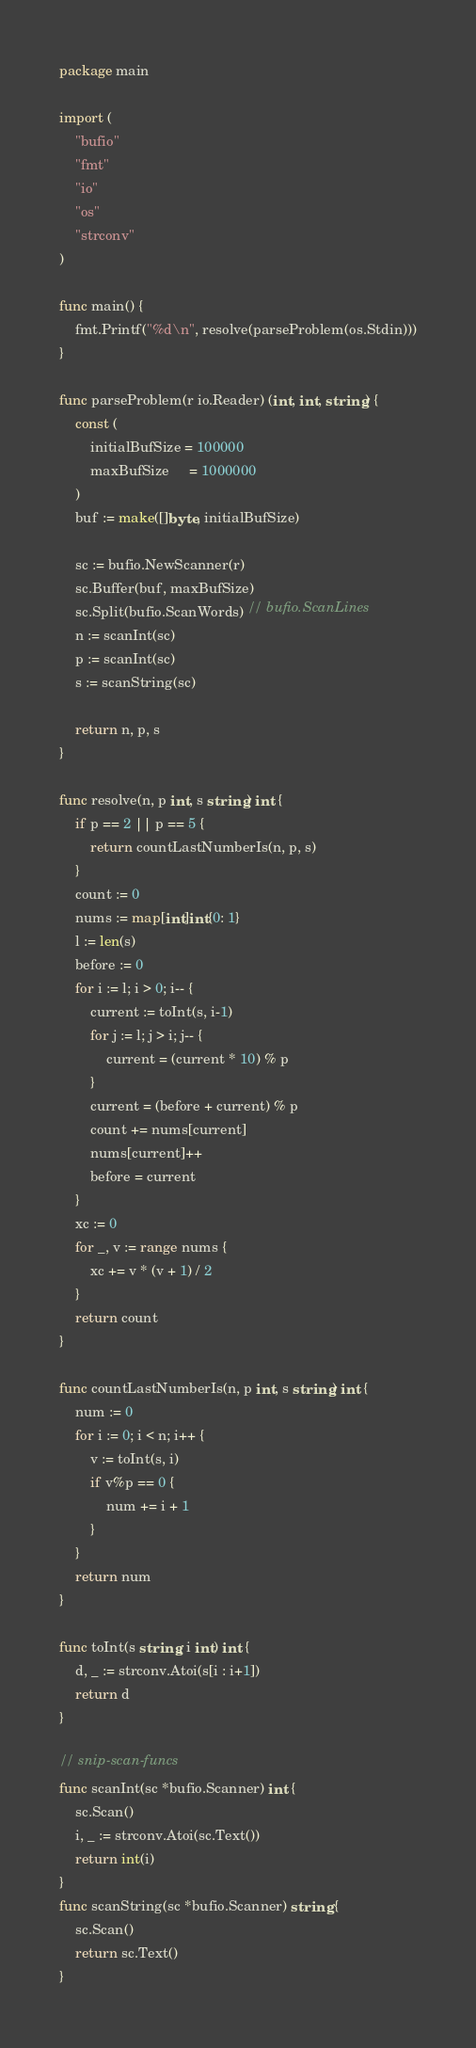<code> <loc_0><loc_0><loc_500><loc_500><_Go_>package main

import (
	"bufio"
	"fmt"
	"io"
	"os"
	"strconv"
)

func main() {
	fmt.Printf("%d\n", resolve(parseProblem(os.Stdin)))
}

func parseProblem(r io.Reader) (int, int, string) {
	const (
		initialBufSize = 100000
		maxBufSize     = 1000000
	)
	buf := make([]byte, initialBufSize)

	sc := bufio.NewScanner(r)
	sc.Buffer(buf, maxBufSize)
	sc.Split(bufio.ScanWords) // bufio.ScanLines
	n := scanInt(sc)
	p := scanInt(sc)
	s := scanString(sc)

	return n, p, s
}

func resolve(n, p int, s string) int {
	if p == 2 || p == 5 {
		return countLastNumberIs(n, p, s)
	}
	count := 0
	nums := map[int]int{0: 1}
	l := len(s)
	before := 0
	for i := l; i > 0; i-- {
		current := toInt(s, i-1)
		for j := l; j > i; j-- {
			current = (current * 10) % p
		}
		current = (before + current) % p
		count += nums[current]
		nums[current]++
		before = current
	}
	xc := 0
	for _, v := range nums {
		xc += v * (v + 1) / 2
	}
	return count
}

func countLastNumberIs(n, p int, s string) int {
	num := 0
	for i := 0; i < n; i++ {
		v := toInt(s, i)
		if v%p == 0 {
			num += i + 1
		}
	}
	return num
}

func toInt(s string, i int) int {
	d, _ := strconv.Atoi(s[i : i+1])
	return d
}

// snip-scan-funcs
func scanInt(sc *bufio.Scanner) int {
	sc.Scan()
	i, _ := strconv.Atoi(sc.Text())
	return int(i)
}
func scanString(sc *bufio.Scanner) string {
	sc.Scan()
	return sc.Text()
}
</code> 